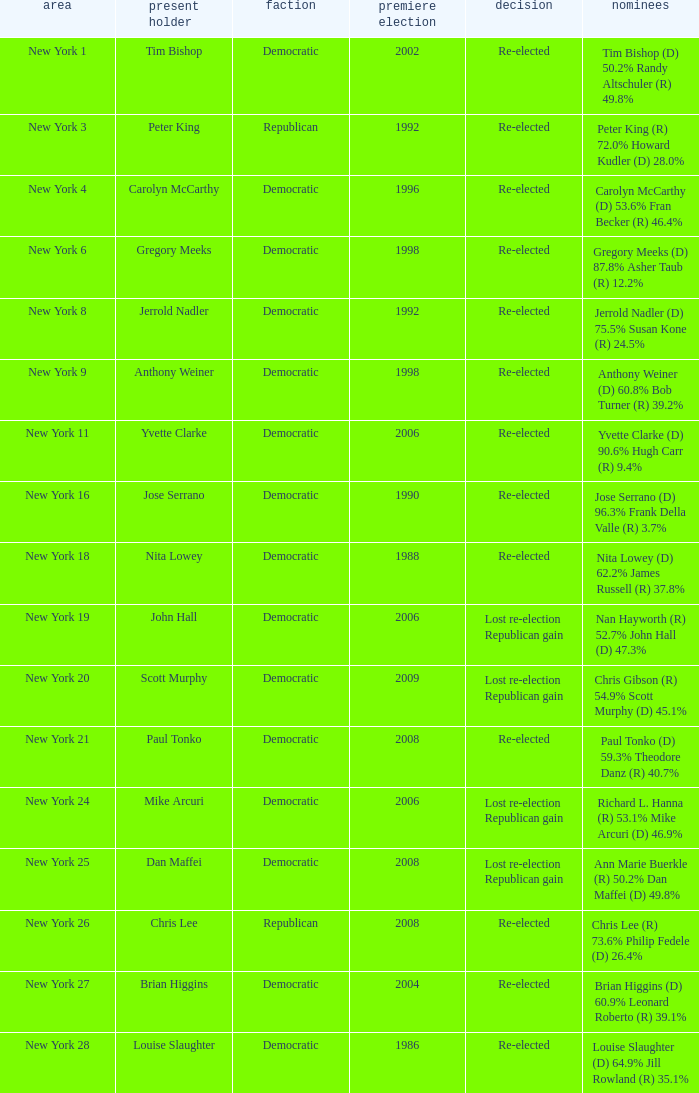Name the party for yvette clarke (d) 90.6% hugh carr (r) 9.4% Democratic. 